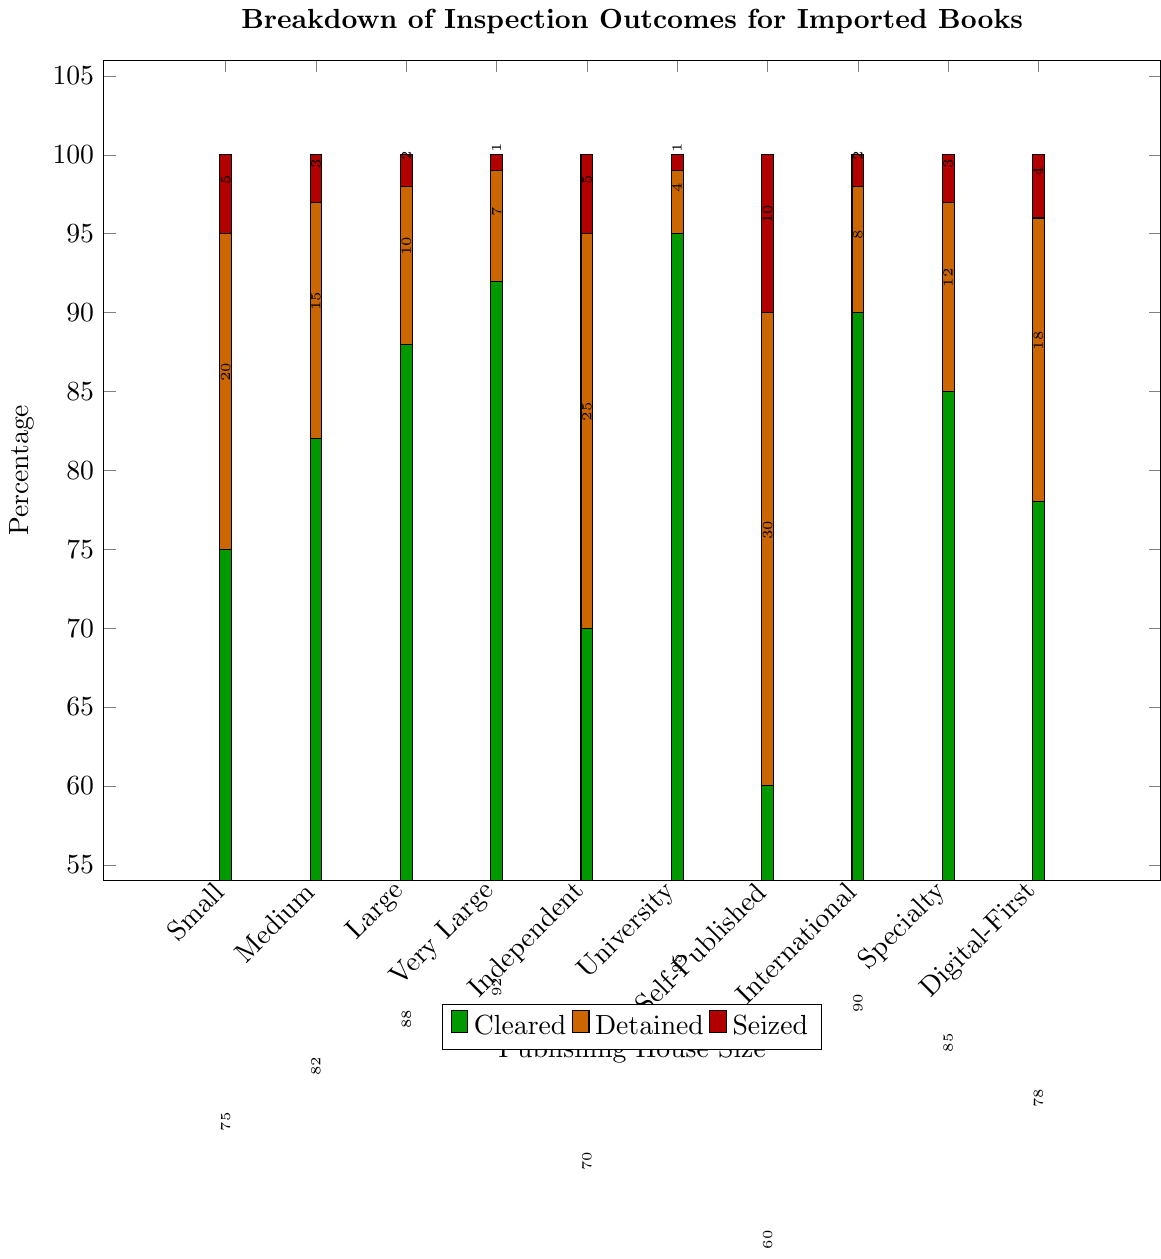What percentage of books from Self-Published houses were detained? By referring to the specific category for Self-Published publishers, we see that the orange bar represents detained books. This bar is labeled with the percentage which is 30%.
Answer: 30% Which publishing house size had the highest percentage of books cleared? The highest green bar represents the cleared books, and University Presses have the highest percentage of 95%.
Answer: University Presses Compare the detained percentages for Independent Publishers and Digital-First Publishers. Which has a higher percentage, and by how much? Independent Publishers have a detained percentage of 25%, while Digital-First Publishers have 18%. The difference is 25% - 18% = 7%.
Answer: Independent Publishers, by 7% What is the total percentage of books either detained or seized for Large publishing houses? Detained percentage for Large houses is 10%, and seized percentage is 2%. Adding them gives 10% + 2% = 12%.
Answer: 12% Among the publishing house sizes, which two categories have an equal percentage of books seized? By examining the red bars, we notice that both Small and Independent Publishing Houses, along with Specialty/Niche Publishers, all have a seized percentage of 5%.
Answer: Small and Independent Publishers Which category has the lowest percentage of detained books, and what is that percentage? The category with the shortest orange bar for detained books is University Presses, with a percentage of 4%.
Answer: University Presses What is the difference in the percentage of cleared books between Large and Small publishing houses? Cleared percentage for Large is 88%, for Small, it is 75%. The difference is 88% - 75% = 13%.
Answer: 13% Calculate the average percentage of books cleared across all publishing house sizes. Adding the cleared percentages for all categories: 75 + 82 + 88 + 92 + 70 + 95 + 60 + 90 + 85 + 78 = 815%. There are ten categories, so the average is 815% / 10 = 81.5%.
Answer: 81.5% What visual feature helps distinguish between the categories of cleared, detained, and seized books? The different colors of the bars (green for cleared, orange for detained, and red for seized) help to visually distinguish between the categories.
Answer: Color (Green, Orange, Red) Which category has the highest percentage difference between cleared and detained books? University Presses have the highest percentage difference between cleared (95%) and detained (4%) books. The difference is 95% - 4% = 91%.
Answer: University Presses 